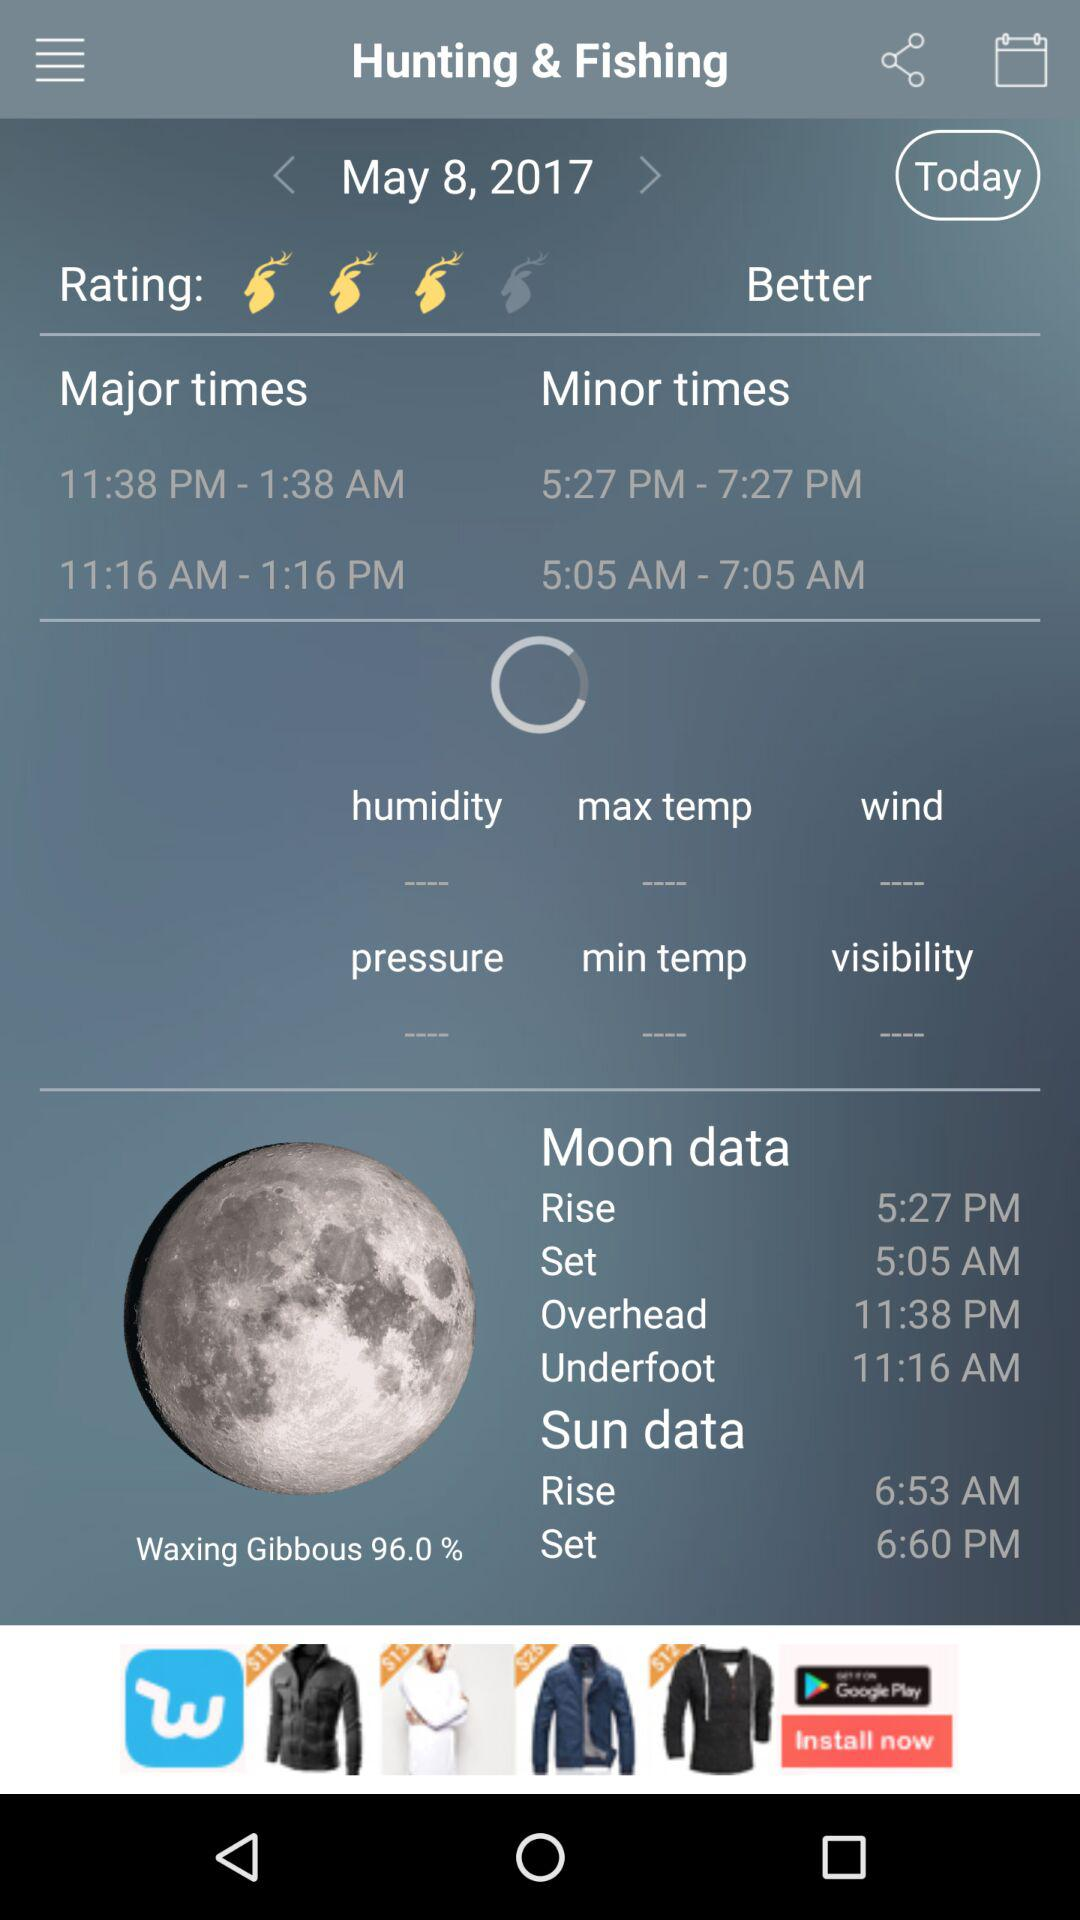What is the given rating?
When the provided information is insufficient, respond with <no answer>. <no answer> 